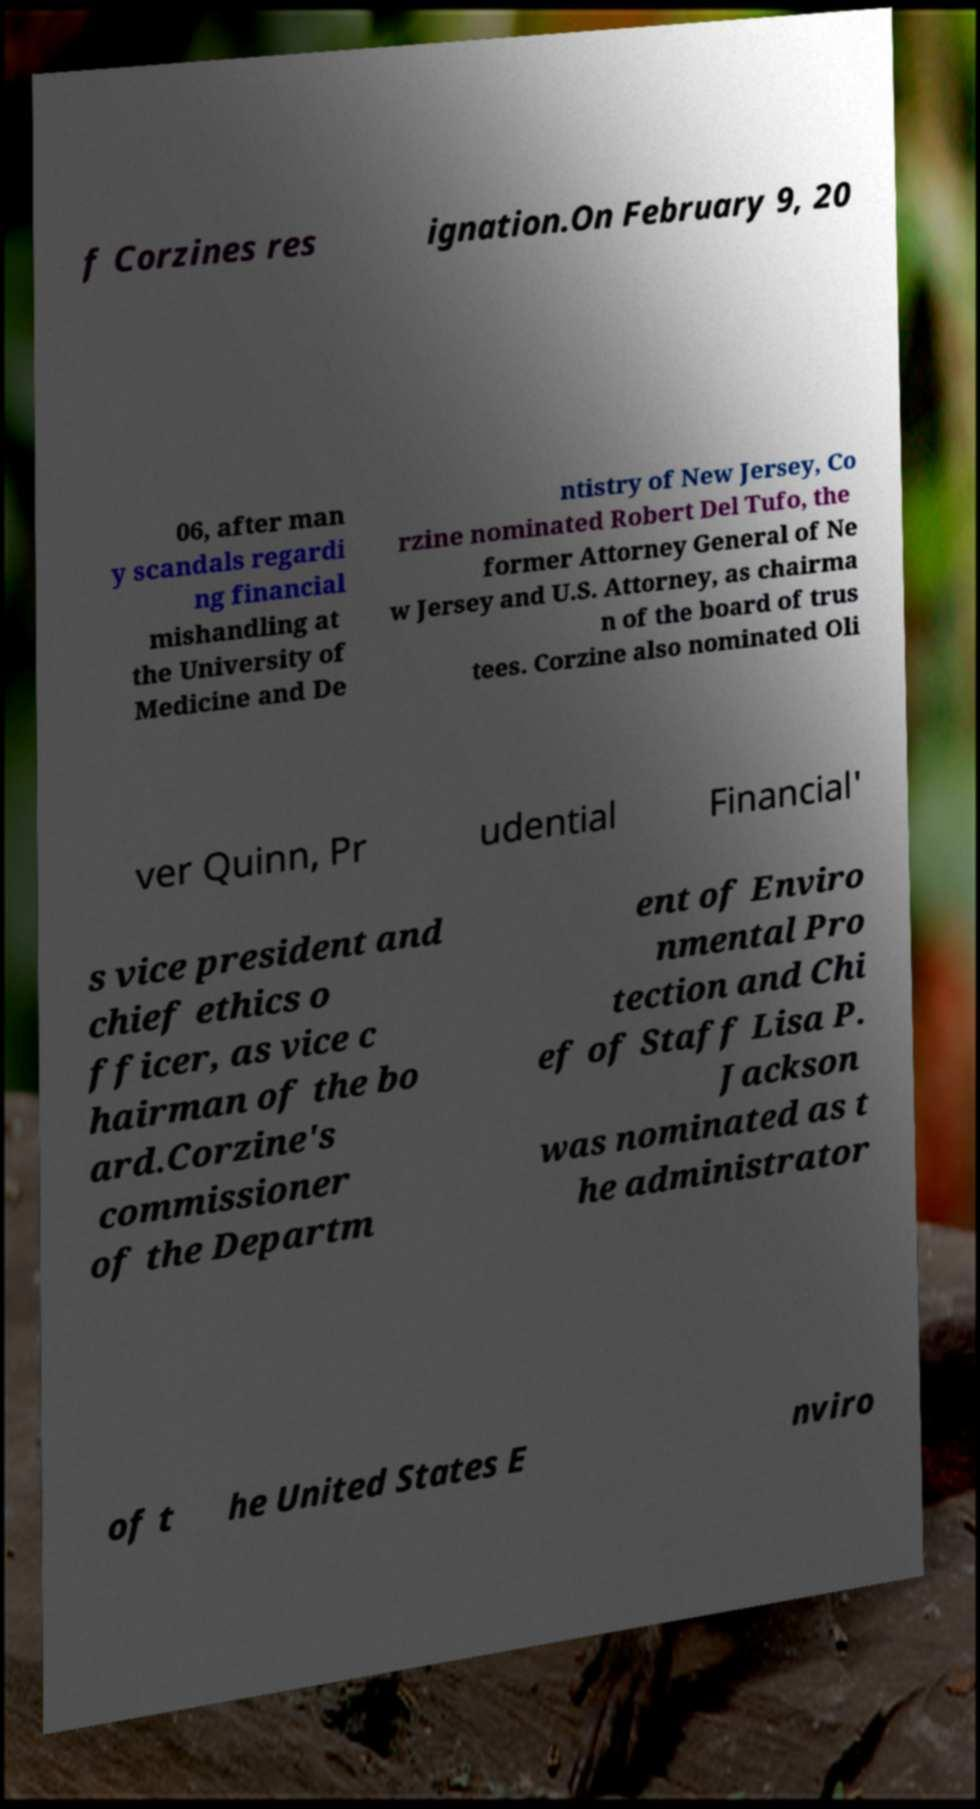I need the written content from this picture converted into text. Can you do that? f Corzines res ignation.On February 9, 20 06, after man y scandals regardi ng financial mishandling at the University of Medicine and De ntistry of New Jersey, Co rzine nominated Robert Del Tufo, the former Attorney General of Ne w Jersey and U.S. Attorney, as chairma n of the board of trus tees. Corzine also nominated Oli ver Quinn, Pr udential Financial' s vice president and chief ethics o fficer, as vice c hairman of the bo ard.Corzine's commissioner of the Departm ent of Enviro nmental Pro tection and Chi ef of Staff Lisa P. Jackson was nominated as t he administrator of t he United States E nviro 